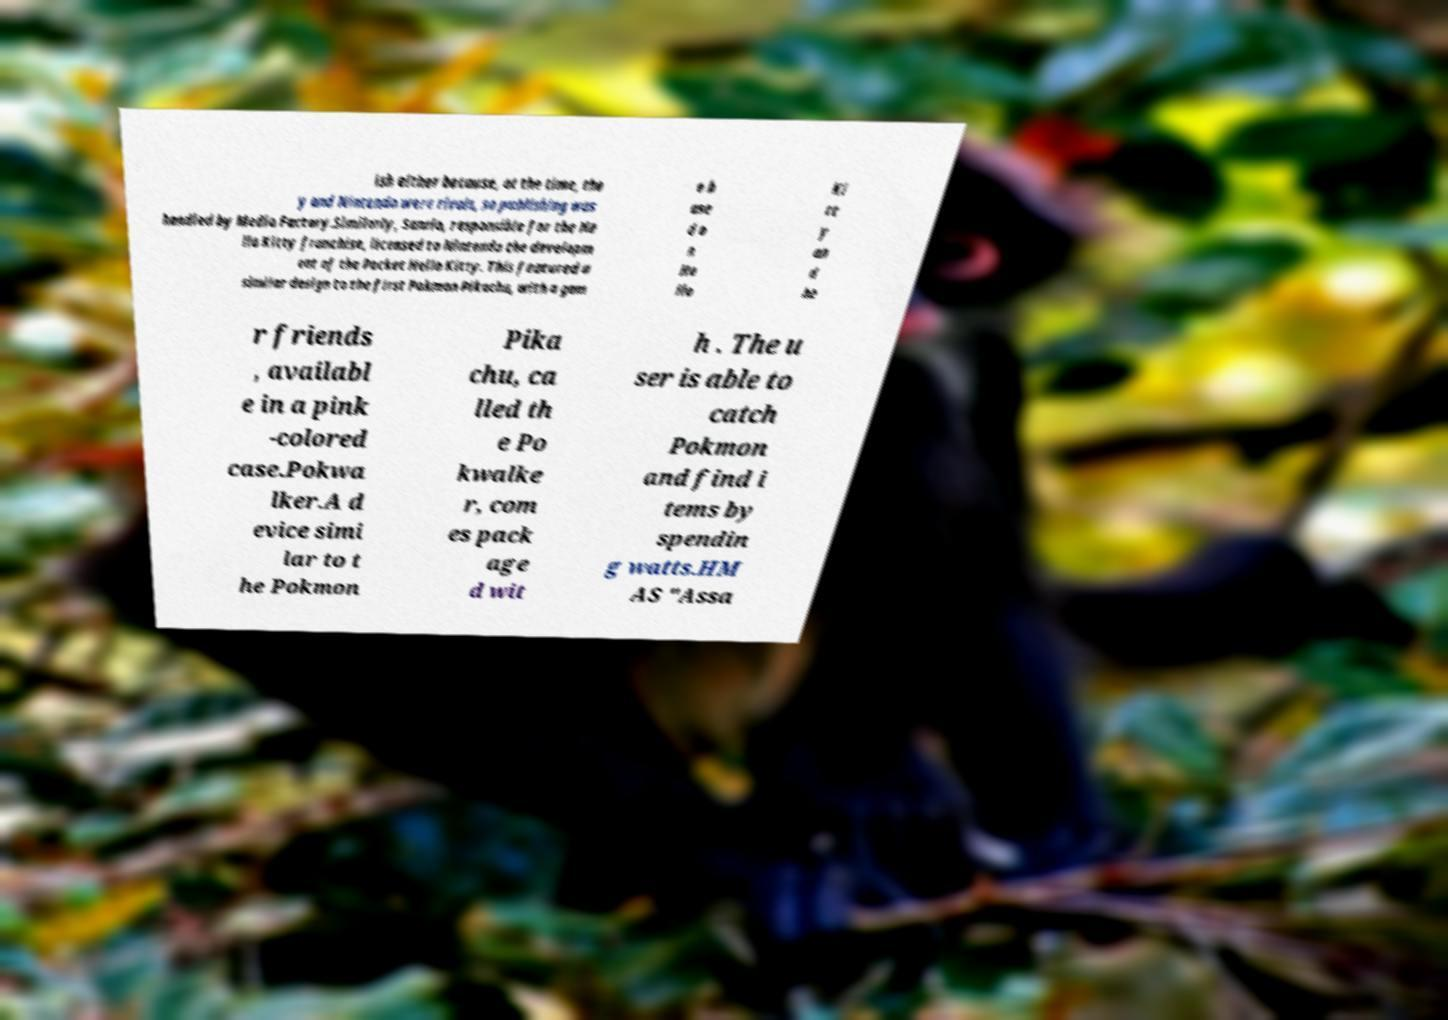I need the written content from this picture converted into text. Can you do that? ish either because, at the time, the y and Nintendo were rivals, so publishing was handled by Media Factory.Similarly, Sanrio, responsible for the He llo Kitty franchise, licensed to Nintendo the developm ent of the Pocket Hello Kitty. This featured a similar design to the first Pokmon Pikachu, with a gam e b ase d o n He llo Ki tt y an d he r friends , availabl e in a pink -colored case.Pokwa lker.A d evice simi lar to t he Pokmon Pika chu, ca lled th e Po kwalke r, com es pack age d wit h . The u ser is able to catch Pokmon and find i tems by spendin g watts.HM AS "Assa 